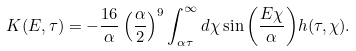<formula> <loc_0><loc_0><loc_500><loc_500>K ( E , \tau ) = - \frac { 1 6 } { \alpha } \left ( \frac { \alpha } { 2 } \right ) ^ { 9 } \int _ { \alpha \tau } ^ { \infty } d \chi \sin { \left ( \frac { E \chi } { \alpha } \right ) } h ( \tau , \chi ) .</formula> 